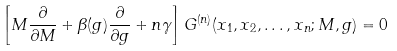Convert formula to latex. <formula><loc_0><loc_0><loc_500><loc_500>\left [ M { \frac { \partial } { \partial M } } + \beta ( g ) { \frac { \partial } { \partial g } } + n \gamma \right ] G ^ { ( n ) } ( x _ { 1 } , x _ { 2 } , \dots , x _ { n } ; M , g ) = 0</formula> 